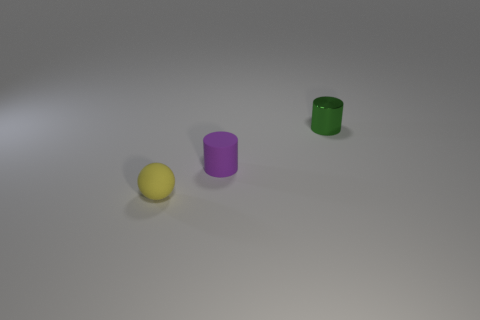Can you describe the shapes and colors of the objects in detail? Certainly! There is a small, spherical object that is yellow in color, likely a rubber ball. Additionally, there are two cylindrical objects, one is purple and the other is green, both having a solid color and a simple, untextured surface. 